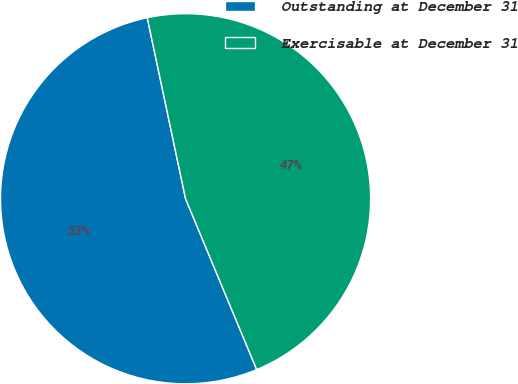Convert chart. <chart><loc_0><loc_0><loc_500><loc_500><pie_chart><fcel>Outstanding at December 31<fcel>Exercisable at December 31<nl><fcel>52.96%<fcel>47.04%<nl></chart> 